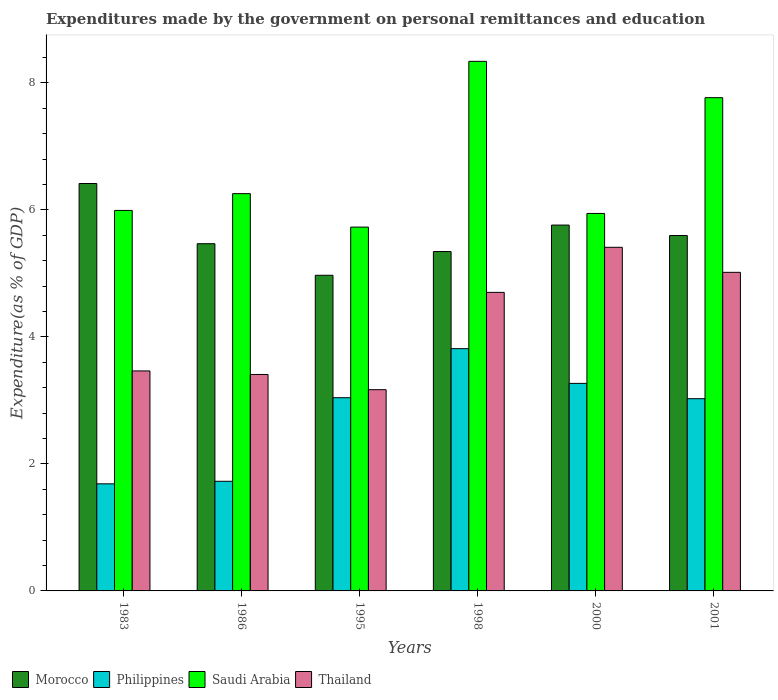Are the number of bars per tick equal to the number of legend labels?
Your answer should be very brief. Yes. How many bars are there on the 1st tick from the right?
Provide a succinct answer. 4. What is the label of the 5th group of bars from the left?
Make the answer very short. 2000. What is the expenditures made by the government on personal remittances and education in Thailand in 1983?
Your response must be concise. 3.46. Across all years, what is the maximum expenditures made by the government on personal remittances and education in Morocco?
Keep it short and to the point. 6.41. Across all years, what is the minimum expenditures made by the government on personal remittances and education in Thailand?
Keep it short and to the point. 3.17. In which year was the expenditures made by the government on personal remittances and education in Saudi Arabia maximum?
Offer a very short reply. 1998. In which year was the expenditures made by the government on personal remittances and education in Philippines minimum?
Offer a terse response. 1983. What is the total expenditures made by the government on personal remittances and education in Morocco in the graph?
Make the answer very short. 33.55. What is the difference between the expenditures made by the government on personal remittances and education in Saudi Arabia in 1995 and that in 1998?
Provide a short and direct response. -2.61. What is the difference between the expenditures made by the government on personal remittances and education in Thailand in 1986 and the expenditures made by the government on personal remittances and education in Philippines in 1998?
Your answer should be very brief. -0.41. What is the average expenditures made by the government on personal remittances and education in Morocco per year?
Provide a short and direct response. 5.59. In the year 1986, what is the difference between the expenditures made by the government on personal remittances and education in Morocco and expenditures made by the government on personal remittances and education in Philippines?
Provide a short and direct response. 3.74. What is the ratio of the expenditures made by the government on personal remittances and education in Thailand in 1998 to that in 2000?
Your response must be concise. 0.87. Is the expenditures made by the government on personal remittances and education in Morocco in 1983 less than that in 1998?
Keep it short and to the point. No. Is the difference between the expenditures made by the government on personal remittances and education in Morocco in 1995 and 2000 greater than the difference between the expenditures made by the government on personal remittances and education in Philippines in 1995 and 2000?
Provide a succinct answer. No. What is the difference between the highest and the second highest expenditures made by the government on personal remittances and education in Philippines?
Provide a short and direct response. 0.55. What is the difference between the highest and the lowest expenditures made by the government on personal remittances and education in Philippines?
Make the answer very short. 2.13. Is the sum of the expenditures made by the government on personal remittances and education in Morocco in 1983 and 1998 greater than the maximum expenditures made by the government on personal remittances and education in Philippines across all years?
Provide a succinct answer. Yes. Is it the case that in every year, the sum of the expenditures made by the government on personal remittances and education in Saudi Arabia and expenditures made by the government on personal remittances and education in Thailand is greater than the sum of expenditures made by the government on personal remittances and education in Philippines and expenditures made by the government on personal remittances and education in Morocco?
Keep it short and to the point. Yes. What does the 2nd bar from the left in 1995 represents?
Your response must be concise. Philippines. What does the 1st bar from the right in 1998 represents?
Ensure brevity in your answer.  Thailand. Is it the case that in every year, the sum of the expenditures made by the government on personal remittances and education in Morocco and expenditures made by the government on personal remittances and education in Thailand is greater than the expenditures made by the government on personal remittances and education in Saudi Arabia?
Provide a short and direct response. Yes. How many bars are there?
Your response must be concise. 24. Are all the bars in the graph horizontal?
Your response must be concise. No. What is the difference between two consecutive major ticks on the Y-axis?
Give a very brief answer. 2. How are the legend labels stacked?
Offer a very short reply. Horizontal. What is the title of the graph?
Offer a terse response. Expenditures made by the government on personal remittances and education. What is the label or title of the X-axis?
Make the answer very short. Years. What is the label or title of the Y-axis?
Your answer should be compact. Expenditure(as % of GDP). What is the Expenditure(as % of GDP) in Morocco in 1983?
Your response must be concise. 6.41. What is the Expenditure(as % of GDP) in Philippines in 1983?
Give a very brief answer. 1.69. What is the Expenditure(as % of GDP) of Saudi Arabia in 1983?
Make the answer very short. 5.99. What is the Expenditure(as % of GDP) in Thailand in 1983?
Keep it short and to the point. 3.46. What is the Expenditure(as % of GDP) of Morocco in 1986?
Keep it short and to the point. 5.47. What is the Expenditure(as % of GDP) in Philippines in 1986?
Your answer should be very brief. 1.73. What is the Expenditure(as % of GDP) of Saudi Arabia in 1986?
Your answer should be compact. 6.26. What is the Expenditure(as % of GDP) in Thailand in 1986?
Keep it short and to the point. 3.41. What is the Expenditure(as % of GDP) of Morocco in 1995?
Ensure brevity in your answer.  4.97. What is the Expenditure(as % of GDP) of Philippines in 1995?
Provide a succinct answer. 3.04. What is the Expenditure(as % of GDP) of Saudi Arabia in 1995?
Provide a short and direct response. 5.73. What is the Expenditure(as % of GDP) in Thailand in 1995?
Your answer should be compact. 3.17. What is the Expenditure(as % of GDP) in Morocco in 1998?
Your response must be concise. 5.34. What is the Expenditure(as % of GDP) in Philippines in 1998?
Offer a very short reply. 3.81. What is the Expenditure(as % of GDP) in Saudi Arabia in 1998?
Keep it short and to the point. 8.34. What is the Expenditure(as % of GDP) of Thailand in 1998?
Keep it short and to the point. 4.7. What is the Expenditure(as % of GDP) of Morocco in 2000?
Keep it short and to the point. 5.76. What is the Expenditure(as % of GDP) in Philippines in 2000?
Your answer should be compact. 3.27. What is the Expenditure(as % of GDP) in Saudi Arabia in 2000?
Make the answer very short. 5.94. What is the Expenditure(as % of GDP) in Thailand in 2000?
Your answer should be compact. 5.41. What is the Expenditure(as % of GDP) in Morocco in 2001?
Make the answer very short. 5.6. What is the Expenditure(as % of GDP) of Philippines in 2001?
Provide a succinct answer. 3.03. What is the Expenditure(as % of GDP) in Saudi Arabia in 2001?
Keep it short and to the point. 7.77. What is the Expenditure(as % of GDP) in Thailand in 2001?
Offer a terse response. 5.02. Across all years, what is the maximum Expenditure(as % of GDP) of Morocco?
Provide a succinct answer. 6.41. Across all years, what is the maximum Expenditure(as % of GDP) in Philippines?
Ensure brevity in your answer.  3.81. Across all years, what is the maximum Expenditure(as % of GDP) in Saudi Arabia?
Keep it short and to the point. 8.34. Across all years, what is the maximum Expenditure(as % of GDP) of Thailand?
Make the answer very short. 5.41. Across all years, what is the minimum Expenditure(as % of GDP) of Morocco?
Your response must be concise. 4.97. Across all years, what is the minimum Expenditure(as % of GDP) in Philippines?
Make the answer very short. 1.69. Across all years, what is the minimum Expenditure(as % of GDP) of Saudi Arabia?
Your answer should be compact. 5.73. Across all years, what is the minimum Expenditure(as % of GDP) of Thailand?
Your response must be concise. 3.17. What is the total Expenditure(as % of GDP) in Morocco in the graph?
Provide a succinct answer. 33.55. What is the total Expenditure(as % of GDP) of Philippines in the graph?
Make the answer very short. 16.56. What is the total Expenditure(as % of GDP) in Saudi Arabia in the graph?
Ensure brevity in your answer.  40.02. What is the total Expenditure(as % of GDP) of Thailand in the graph?
Make the answer very short. 25.17. What is the difference between the Expenditure(as % of GDP) in Morocco in 1983 and that in 1986?
Provide a short and direct response. 0.95. What is the difference between the Expenditure(as % of GDP) in Philippines in 1983 and that in 1986?
Give a very brief answer. -0.04. What is the difference between the Expenditure(as % of GDP) in Saudi Arabia in 1983 and that in 1986?
Offer a terse response. -0.26. What is the difference between the Expenditure(as % of GDP) of Thailand in 1983 and that in 1986?
Your answer should be very brief. 0.06. What is the difference between the Expenditure(as % of GDP) of Morocco in 1983 and that in 1995?
Your response must be concise. 1.44. What is the difference between the Expenditure(as % of GDP) of Philippines in 1983 and that in 1995?
Offer a terse response. -1.36. What is the difference between the Expenditure(as % of GDP) of Saudi Arabia in 1983 and that in 1995?
Offer a terse response. 0.26. What is the difference between the Expenditure(as % of GDP) of Thailand in 1983 and that in 1995?
Ensure brevity in your answer.  0.3. What is the difference between the Expenditure(as % of GDP) in Morocco in 1983 and that in 1998?
Your answer should be very brief. 1.07. What is the difference between the Expenditure(as % of GDP) of Philippines in 1983 and that in 1998?
Give a very brief answer. -2.13. What is the difference between the Expenditure(as % of GDP) of Saudi Arabia in 1983 and that in 1998?
Make the answer very short. -2.35. What is the difference between the Expenditure(as % of GDP) of Thailand in 1983 and that in 1998?
Provide a short and direct response. -1.24. What is the difference between the Expenditure(as % of GDP) of Morocco in 1983 and that in 2000?
Make the answer very short. 0.65. What is the difference between the Expenditure(as % of GDP) of Philippines in 1983 and that in 2000?
Ensure brevity in your answer.  -1.58. What is the difference between the Expenditure(as % of GDP) in Saudi Arabia in 1983 and that in 2000?
Your response must be concise. 0.05. What is the difference between the Expenditure(as % of GDP) of Thailand in 1983 and that in 2000?
Your answer should be compact. -1.95. What is the difference between the Expenditure(as % of GDP) in Morocco in 1983 and that in 2001?
Provide a succinct answer. 0.82. What is the difference between the Expenditure(as % of GDP) of Philippines in 1983 and that in 2001?
Keep it short and to the point. -1.34. What is the difference between the Expenditure(as % of GDP) of Saudi Arabia in 1983 and that in 2001?
Make the answer very short. -1.78. What is the difference between the Expenditure(as % of GDP) in Thailand in 1983 and that in 2001?
Ensure brevity in your answer.  -1.55. What is the difference between the Expenditure(as % of GDP) of Morocco in 1986 and that in 1995?
Provide a succinct answer. 0.5. What is the difference between the Expenditure(as % of GDP) of Philippines in 1986 and that in 1995?
Provide a short and direct response. -1.32. What is the difference between the Expenditure(as % of GDP) of Saudi Arabia in 1986 and that in 1995?
Provide a succinct answer. 0.53. What is the difference between the Expenditure(as % of GDP) of Thailand in 1986 and that in 1995?
Your answer should be compact. 0.24. What is the difference between the Expenditure(as % of GDP) in Morocco in 1986 and that in 1998?
Provide a short and direct response. 0.12. What is the difference between the Expenditure(as % of GDP) of Philippines in 1986 and that in 1998?
Your answer should be very brief. -2.09. What is the difference between the Expenditure(as % of GDP) in Saudi Arabia in 1986 and that in 1998?
Your response must be concise. -2.08. What is the difference between the Expenditure(as % of GDP) of Thailand in 1986 and that in 1998?
Give a very brief answer. -1.29. What is the difference between the Expenditure(as % of GDP) of Morocco in 1986 and that in 2000?
Your response must be concise. -0.29. What is the difference between the Expenditure(as % of GDP) in Philippines in 1986 and that in 2000?
Make the answer very short. -1.54. What is the difference between the Expenditure(as % of GDP) in Saudi Arabia in 1986 and that in 2000?
Your response must be concise. 0.31. What is the difference between the Expenditure(as % of GDP) of Thailand in 1986 and that in 2000?
Keep it short and to the point. -2. What is the difference between the Expenditure(as % of GDP) of Morocco in 1986 and that in 2001?
Provide a short and direct response. -0.13. What is the difference between the Expenditure(as % of GDP) of Philippines in 1986 and that in 2001?
Ensure brevity in your answer.  -1.3. What is the difference between the Expenditure(as % of GDP) in Saudi Arabia in 1986 and that in 2001?
Your response must be concise. -1.51. What is the difference between the Expenditure(as % of GDP) of Thailand in 1986 and that in 2001?
Provide a short and direct response. -1.61. What is the difference between the Expenditure(as % of GDP) in Morocco in 1995 and that in 1998?
Your answer should be compact. -0.37. What is the difference between the Expenditure(as % of GDP) in Philippines in 1995 and that in 1998?
Provide a short and direct response. -0.77. What is the difference between the Expenditure(as % of GDP) of Saudi Arabia in 1995 and that in 1998?
Your response must be concise. -2.61. What is the difference between the Expenditure(as % of GDP) in Thailand in 1995 and that in 1998?
Keep it short and to the point. -1.53. What is the difference between the Expenditure(as % of GDP) in Morocco in 1995 and that in 2000?
Provide a short and direct response. -0.79. What is the difference between the Expenditure(as % of GDP) of Philippines in 1995 and that in 2000?
Keep it short and to the point. -0.23. What is the difference between the Expenditure(as % of GDP) in Saudi Arabia in 1995 and that in 2000?
Your answer should be very brief. -0.22. What is the difference between the Expenditure(as % of GDP) in Thailand in 1995 and that in 2000?
Your answer should be compact. -2.24. What is the difference between the Expenditure(as % of GDP) of Morocco in 1995 and that in 2001?
Your answer should be very brief. -0.63. What is the difference between the Expenditure(as % of GDP) in Philippines in 1995 and that in 2001?
Give a very brief answer. 0.02. What is the difference between the Expenditure(as % of GDP) in Saudi Arabia in 1995 and that in 2001?
Offer a terse response. -2.04. What is the difference between the Expenditure(as % of GDP) in Thailand in 1995 and that in 2001?
Provide a short and direct response. -1.85. What is the difference between the Expenditure(as % of GDP) of Morocco in 1998 and that in 2000?
Offer a very short reply. -0.42. What is the difference between the Expenditure(as % of GDP) of Philippines in 1998 and that in 2000?
Your answer should be compact. 0.55. What is the difference between the Expenditure(as % of GDP) of Saudi Arabia in 1998 and that in 2000?
Offer a very short reply. 2.39. What is the difference between the Expenditure(as % of GDP) of Thailand in 1998 and that in 2000?
Your answer should be compact. -0.71. What is the difference between the Expenditure(as % of GDP) of Morocco in 1998 and that in 2001?
Offer a very short reply. -0.25. What is the difference between the Expenditure(as % of GDP) in Philippines in 1998 and that in 2001?
Offer a terse response. 0.79. What is the difference between the Expenditure(as % of GDP) in Saudi Arabia in 1998 and that in 2001?
Your answer should be very brief. 0.57. What is the difference between the Expenditure(as % of GDP) in Thailand in 1998 and that in 2001?
Provide a succinct answer. -0.32. What is the difference between the Expenditure(as % of GDP) of Morocco in 2000 and that in 2001?
Your response must be concise. 0.16. What is the difference between the Expenditure(as % of GDP) in Philippines in 2000 and that in 2001?
Make the answer very short. 0.24. What is the difference between the Expenditure(as % of GDP) in Saudi Arabia in 2000 and that in 2001?
Make the answer very short. -1.82. What is the difference between the Expenditure(as % of GDP) in Thailand in 2000 and that in 2001?
Your answer should be compact. 0.39. What is the difference between the Expenditure(as % of GDP) in Morocco in 1983 and the Expenditure(as % of GDP) in Philippines in 1986?
Offer a very short reply. 4.69. What is the difference between the Expenditure(as % of GDP) of Morocco in 1983 and the Expenditure(as % of GDP) of Saudi Arabia in 1986?
Offer a terse response. 0.16. What is the difference between the Expenditure(as % of GDP) in Morocco in 1983 and the Expenditure(as % of GDP) in Thailand in 1986?
Ensure brevity in your answer.  3.01. What is the difference between the Expenditure(as % of GDP) in Philippines in 1983 and the Expenditure(as % of GDP) in Saudi Arabia in 1986?
Offer a terse response. -4.57. What is the difference between the Expenditure(as % of GDP) of Philippines in 1983 and the Expenditure(as % of GDP) of Thailand in 1986?
Ensure brevity in your answer.  -1.72. What is the difference between the Expenditure(as % of GDP) in Saudi Arabia in 1983 and the Expenditure(as % of GDP) in Thailand in 1986?
Provide a succinct answer. 2.58. What is the difference between the Expenditure(as % of GDP) of Morocco in 1983 and the Expenditure(as % of GDP) of Philippines in 1995?
Your answer should be very brief. 3.37. What is the difference between the Expenditure(as % of GDP) in Morocco in 1983 and the Expenditure(as % of GDP) in Saudi Arabia in 1995?
Keep it short and to the point. 0.69. What is the difference between the Expenditure(as % of GDP) of Morocco in 1983 and the Expenditure(as % of GDP) of Thailand in 1995?
Your response must be concise. 3.25. What is the difference between the Expenditure(as % of GDP) in Philippines in 1983 and the Expenditure(as % of GDP) in Saudi Arabia in 1995?
Your answer should be compact. -4.04. What is the difference between the Expenditure(as % of GDP) in Philippines in 1983 and the Expenditure(as % of GDP) in Thailand in 1995?
Keep it short and to the point. -1.48. What is the difference between the Expenditure(as % of GDP) of Saudi Arabia in 1983 and the Expenditure(as % of GDP) of Thailand in 1995?
Offer a terse response. 2.82. What is the difference between the Expenditure(as % of GDP) in Morocco in 1983 and the Expenditure(as % of GDP) in Philippines in 1998?
Provide a short and direct response. 2.6. What is the difference between the Expenditure(as % of GDP) of Morocco in 1983 and the Expenditure(as % of GDP) of Saudi Arabia in 1998?
Ensure brevity in your answer.  -1.92. What is the difference between the Expenditure(as % of GDP) of Morocco in 1983 and the Expenditure(as % of GDP) of Thailand in 1998?
Keep it short and to the point. 1.71. What is the difference between the Expenditure(as % of GDP) in Philippines in 1983 and the Expenditure(as % of GDP) in Saudi Arabia in 1998?
Provide a short and direct response. -6.65. What is the difference between the Expenditure(as % of GDP) of Philippines in 1983 and the Expenditure(as % of GDP) of Thailand in 1998?
Your answer should be very brief. -3.01. What is the difference between the Expenditure(as % of GDP) of Saudi Arabia in 1983 and the Expenditure(as % of GDP) of Thailand in 1998?
Give a very brief answer. 1.29. What is the difference between the Expenditure(as % of GDP) in Morocco in 1983 and the Expenditure(as % of GDP) in Philippines in 2000?
Provide a short and direct response. 3.15. What is the difference between the Expenditure(as % of GDP) in Morocco in 1983 and the Expenditure(as % of GDP) in Saudi Arabia in 2000?
Ensure brevity in your answer.  0.47. What is the difference between the Expenditure(as % of GDP) of Philippines in 1983 and the Expenditure(as % of GDP) of Saudi Arabia in 2000?
Your answer should be very brief. -4.26. What is the difference between the Expenditure(as % of GDP) in Philippines in 1983 and the Expenditure(as % of GDP) in Thailand in 2000?
Give a very brief answer. -3.72. What is the difference between the Expenditure(as % of GDP) of Saudi Arabia in 1983 and the Expenditure(as % of GDP) of Thailand in 2000?
Give a very brief answer. 0.58. What is the difference between the Expenditure(as % of GDP) of Morocco in 1983 and the Expenditure(as % of GDP) of Philippines in 2001?
Offer a terse response. 3.39. What is the difference between the Expenditure(as % of GDP) in Morocco in 1983 and the Expenditure(as % of GDP) in Saudi Arabia in 2001?
Provide a succinct answer. -1.35. What is the difference between the Expenditure(as % of GDP) of Morocco in 1983 and the Expenditure(as % of GDP) of Thailand in 2001?
Provide a short and direct response. 1.4. What is the difference between the Expenditure(as % of GDP) in Philippines in 1983 and the Expenditure(as % of GDP) in Saudi Arabia in 2001?
Provide a succinct answer. -6.08. What is the difference between the Expenditure(as % of GDP) in Philippines in 1983 and the Expenditure(as % of GDP) in Thailand in 2001?
Provide a succinct answer. -3.33. What is the difference between the Expenditure(as % of GDP) in Saudi Arabia in 1983 and the Expenditure(as % of GDP) in Thailand in 2001?
Ensure brevity in your answer.  0.97. What is the difference between the Expenditure(as % of GDP) of Morocco in 1986 and the Expenditure(as % of GDP) of Philippines in 1995?
Offer a terse response. 2.42. What is the difference between the Expenditure(as % of GDP) of Morocco in 1986 and the Expenditure(as % of GDP) of Saudi Arabia in 1995?
Make the answer very short. -0.26. What is the difference between the Expenditure(as % of GDP) of Morocco in 1986 and the Expenditure(as % of GDP) of Thailand in 1995?
Your answer should be very brief. 2.3. What is the difference between the Expenditure(as % of GDP) in Philippines in 1986 and the Expenditure(as % of GDP) in Saudi Arabia in 1995?
Provide a succinct answer. -4. What is the difference between the Expenditure(as % of GDP) of Philippines in 1986 and the Expenditure(as % of GDP) of Thailand in 1995?
Your answer should be compact. -1.44. What is the difference between the Expenditure(as % of GDP) in Saudi Arabia in 1986 and the Expenditure(as % of GDP) in Thailand in 1995?
Make the answer very short. 3.09. What is the difference between the Expenditure(as % of GDP) in Morocco in 1986 and the Expenditure(as % of GDP) in Philippines in 1998?
Keep it short and to the point. 1.65. What is the difference between the Expenditure(as % of GDP) of Morocco in 1986 and the Expenditure(as % of GDP) of Saudi Arabia in 1998?
Keep it short and to the point. -2.87. What is the difference between the Expenditure(as % of GDP) of Morocco in 1986 and the Expenditure(as % of GDP) of Thailand in 1998?
Your answer should be very brief. 0.77. What is the difference between the Expenditure(as % of GDP) of Philippines in 1986 and the Expenditure(as % of GDP) of Saudi Arabia in 1998?
Make the answer very short. -6.61. What is the difference between the Expenditure(as % of GDP) of Philippines in 1986 and the Expenditure(as % of GDP) of Thailand in 1998?
Your answer should be compact. -2.97. What is the difference between the Expenditure(as % of GDP) in Saudi Arabia in 1986 and the Expenditure(as % of GDP) in Thailand in 1998?
Give a very brief answer. 1.55. What is the difference between the Expenditure(as % of GDP) of Morocco in 1986 and the Expenditure(as % of GDP) of Philippines in 2000?
Provide a succinct answer. 2.2. What is the difference between the Expenditure(as % of GDP) in Morocco in 1986 and the Expenditure(as % of GDP) in Saudi Arabia in 2000?
Provide a short and direct response. -0.48. What is the difference between the Expenditure(as % of GDP) in Morocco in 1986 and the Expenditure(as % of GDP) in Thailand in 2000?
Your answer should be compact. 0.06. What is the difference between the Expenditure(as % of GDP) of Philippines in 1986 and the Expenditure(as % of GDP) of Saudi Arabia in 2000?
Keep it short and to the point. -4.22. What is the difference between the Expenditure(as % of GDP) of Philippines in 1986 and the Expenditure(as % of GDP) of Thailand in 2000?
Offer a terse response. -3.68. What is the difference between the Expenditure(as % of GDP) of Saudi Arabia in 1986 and the Expenditure(as % of GDP) of Thailand in 2000?
Your answer should be very brief. 0.84. What is the difference between the Expenditure(as % of GDP) of Morocco in 1986 and the Expenditure(as % of GDP) of Philippines in 2001?
Offer a terse response. 2.44. What is the difference between the Expenditure(as % of GDP) of Morocco in 1986 and the Expenditure(as % of GDP) of Saudi Arabia in 2001?
Your answer should be compact. -2.3. What is the difference between the Expenditure(as % of GDP) in Morocco in 1986 and the Expenditure(as % of GDP) in Thailand in 2001?
Give a very brief answer. 0.45. What is the difference between the Expenditure(as % of GDP) in Philippines in 1986 and the Expenditure(as % of GDP) in Saudi Arabia in 2001?
Your answer should be very brief. -6.04. What is the difference between the Expenditure(as % of GDP) in Philippines in 1986 and the Expenditure(as % of GDP) in Thailand in 2001?
Keep it short and to the point. -3.29. What is the difference between the Expenditure(as % of GDP) in Saudi Arabia in 1986 and the Expenditure(as % of GDP) in Thailand in 2001?
Your answer should be compact. 1.24. What is the difference between the Expenditure(as % of GDP) in Morocco in 1995 and the Expenditure(as % of GDP) in Philippines in 1998?
Provide a succinct answer. 1.16. What is the difference between the Expenditure(as % of GDP) in Morocco in 1995 and the Expenditure(as % of GDP) in Saudi Arabia in 1998?
Your answer should be very brief. -3.37. What is the difference between the Expenditure(as % of GDP) in Morocco in 1995 and the Expenditure(as % of GDP) in Thailand in 1998?
Your answer should be very brief. 0.27. What is the difference between the Expenditure(as % of GDP) in Philippines in 1995 and the Expenditure(as % of GDP) in Saudi Arabia in 1998?
Keep it short and to the point. -5.3. What is the difference between the Expenditure(as % of GDP) in Philippines in 1995 and the Expenditure(as % of GDP) in Thailand in 1998?
Make the answer very short. -1.66. What is the difference between the Expenditure(as % of GDP) in Saudi Arabia in 1995 and the Expenditure(as % of GDP) in Thailand in 1998?
Your response must be concise. 1.03. What is the difference between the Expenditure(as % of GDP) of Morocco in 1995 and the Expenditure(as % of GDP) of Philippines in 2000?
Make the answer very short. 1.7. What is the difference between the Expenditure(as % of GDP) of Morocco in 1995 and the Expenditure(as % of GDP) of Saudi Arabia in 2000?
Give a very brief answer. -0.97. What is the difference between the Expenditure(as % of GDP) of Morocco in 1995 and the Expenditure(as % of GDP) of Thailand in 2000?
Offer a terse response. -0.44. What is the difference between the Expenditure(as % of GDP) of Philippines in 1995 and the Expenditure(as % of GDP) of Saudi Arabia in 2000?
Keep it short and to the point. -2.9. What is the difference between the Expenditure(as % of GDP) of Philippines in 1995 and the Expenditure(as % of GDP) of Thailand in 2000?
Your response must be concise. -2.37. What is the difference between the Expenditure(as % of GDP) of Saudi Arabia in 1995 and the Expenditure(as % of GDP) of Thailand in 2000?
Offer a very short reply. 0.32. What is the difference between the Expenditure(as % of GDP) of Morocco in 1995 and the Expenditure(as % of GDP) of Philippines in 2001?
Give a very brief answer. 1.94. What is the difference between the Expenditure(as % of GDP) of Morocco in 1995 and the Expenditure(as % of GDP) of Saudi Arabia in 2001?
Ensure brevity in your answer.  -2.8. What is the difference between the Expenditure(as % of GDP) of Morocco in 1995 and the Expenditure(as % of GDP) of Thailand in 2001?
Provide a short and direct response. -0.05. What is the difference between the Expenditure(as % of GDP) of Philippines in 1995 and the Expenditure(as % of GDP) of Saudi Arabia in 2001?
Give a very brief answer. -4.72. What is the difference between the Expenditure(as % of GDP) in Philippines in 1995 and the Expenditure(as % of GDP) in Thailand in 2001?
Your answer should be very brief. -1.97. What is the difference between the Expenditure(as % of GDP) in Saudi Arabia in 1995 and the Expenditure(as % of GDP) in Thailand in 2001?
Ensure brevity in your answer.  0.71. What is the difference between the Expenditure(as % of GDP) of Morocco in 1998 and the Expenditure(as % of GDP) of Philippines in 2000?
Offer a terse response. 2.08. What is the difference between the Expenditure(as % of GDP) in Morocco in 1998 and the Expenditure(as % of GDP) in Saudi Arabia in 2000?
Offer a terse response. -0.6. What is the difference between the Expenditure(as % of GDP) in Morocco in 1998 and the Expenditure(as % of GDP) in Thailand in 2000?
Your answer should be compact. -0.07. What is the difference between the Expenditure(as % of GDP) in Philippines in 1998 and the Expenditure(as % of GDP) in Saudi Arabia in 2000?
Offer a very short reply. -2.13. What is the difference between the Expenditure(as % of GDP) of Philippines in 1998 and the Expenditure(as % of GDP) of Thailand in 2000?
Your answer should be compact. -1.6. What is the difference between the Expenditure(as % of GDP) of Saudi Arabia in 1998 and the Expenditure(as % of GDP) of Thailand in 2000?
Offer a terse response. 2.93. What is the difference between the Expenditure(as % of GDP) in Morocco in 1998 and the Expenditure(as % of GDP) in Philippines in 2001?
Make the answer very short. 2.32. What is the difference between the Expenditure(as % of GDP) of Morocco in 1998 and the Expenditure(as % of GDP) of Saudi Arabia in 2001?
Offer a very short reply. -2.42. What is the difference between the Expenditure(as % of GDP) in Morocco in 1998 and the Expenditure(as % of GDP) in Thailand in 2001?
Offer a terse response. 0.33. What is the difference between the Expenditure(as % of GDP) of Philippines in 1998 and the Expenditure(as % of GDP) of Saudi Arabia in 2001?
Keep it short and to the point. -3.95. What is the difference between the Expenditure(as % of GDP) of Philippines in 1998 and the Expenditure(as % of GDP) of Thailand in 2001?
Offer a terse response. -1.2. What is the difference between the Expenditure(as % of GDP) in Saudi Arabia in 1998 and the Expenditure(as % of GDP) in Thailand in 2001?
Make the answer very short. 3.32. What is the difference between the Expenditure(as % of GDP) in Morocco in 2000 and the Expenditure(as % of GDP) in Philippines in 2001?
Provide a succinct answer. 2.73. What is the difference between the Expenditure(as % of GDP) of Morocco in 2000 and the Expenditure(as % of GDP) of Saudi Arabia in 2001?
Provide a succinct answer. -2.01. What is the difference between the Expenditure(as % of GDP) of Morocco in 2000 and the Expenditure(as % of GDP) of Thailand in 2001?
Provide a succinct answer. 0.74. What is the difference between the Expenditure(as % of GDP) in Philippines in 2000 and the Expenditure(as % of GDP) in Saudi Arabia in 2001?
Your response must be concise. -4.5. What is the difference between the Expenditure(as % of GDP) of Philippines in 2000 and the Expenditure(as % of GDP) of Thailand in 2001?
Make the answer very short. -1.75. What is the difference between the Expenditure(as % of GDP) of Saudi Arabia in 2000 and the Expenditure(as % of GDP) of Thailand in 2001?
Make the answer very short. 0.93. What is the average Expenditure(as % of GDP) in Morocco per year?
Provide a short and direct response. 5.59. What is the average Expenditure(as % of GDP) of Philippines per year?
Give a very brief answer. 2.76. What is the average Expenditure(as % of GDP) of Saudi Arabia per year?
Provide a succinct answer. 6.67. What is the average Expenditure(as % of GDP) in Thailand per year?
Provide a short and direct response. 4.19. In the year 1983, what is the difference between the Expenditure(as % of GDP) of Morocco and Expenditure(as % of GDP) of Philippines?
Provide a succinct answer. 4.73. In the year 1983, what is the difference between the Expenditure(as % of GDP) of Morocco and Expenditure(as % of GDP) of Saudi Arabia?
Your answer should be very brief. 0.42. In the year 1983, what is the difference between the Expenditure(as % of GDP) in Morocco and Expenditure(as % of GDP) in Thailand?
Make the answer very short. 2.95. In the year 1983, what is the difference between the Expenditure(as % of GDP) of Philippines and Expenditure(as % of GDP) of Saudi Arabia?
Your answer should be compact. -4.3. In the year 1983, what is the difference between the Expenditure(as % of GDP) in Philippines and Expenditure(as % of GDP) in Thailand?
Your response must be concise. -1.78. In the year 1983, what is the difference between the Expenditure(as % of GDP) of Saudi Arabia and Expenditure(as % of GDP) of Thailand?
Your response must be concise. 2.53. In the year 1986, what is the difference between the Expenditure(as % of GDP) of Morocco and Expenditure(as % of GDP) of Philippines?
Your response must be concise. 3.74. In the year 1986, what is the difference between the Expenditure(as % of GDP) of Morocco and Expenditure(as % of GDP) of Saudi Arabia?
Make the answer very short. -0.79. In the year 1986, what is the difference between the Expenditure(as % of GDP) in Morocco and Expenditure(as % of GDP) in Thailand?
Your answer should be very brief. 2.06. In the year 1986, what is the difference between the Expenditure(as % of GDP) of Philippines and Expenditure(as % of GDP) of Saudi Arabia?
Your answer should be very brief. -4.53. In the year 1986, what is the difference between the Expenditure(as % of GDP) in Philippines and Expenditure(as % of GDP) in Thailand?
Provide a short and direct response. -1.68. In the year 1986, what is the difference between the Expenditure(as % of GDP) in Saudi Arabia and Expenditure(as % of GDP) in Thailand?
Give a very brief answer. 2.85. In the year 1995, what is the difference between the Expenditure(as % of GDP) in Morocco and Expenditure(as % of GDP) in Philippines?
Make the answer very short. 1.93. In the year 1995, what is the difference between the Expenditure(as % of GDP) in Morocco and Expenditure(as % of GDP) in Saudi Arabia?
Offer a terse response. -0.76. In the year 1995, what is the difference between the Expenditure(as % of GDP) of Morocco and Expenditure(as % of GDP) of Thailand?
Provide a succinct answer. 1.8. In the year 1995, what is the difference between the Expenditure(as % of GDP) of Philippines and Expenditure(as % of GDP) of Saudi Arabia?
Give a very brief answer. -2.69. In the year 1995, what is the difference between the Expenditure(as % of GDP) of Philippines and Expenditure(as % of GDP) of Thailand?
Provide a short and direct response. -0.13. In the year 1995, what is the difference between the Expenditure(as % of GDP) of Saudi Arabia and Expenditure(as % of GDP) of Thailand?
Make the answer very short. 2.56. In the year 1998, what is the difference between the Expenditure(as % of GDP) of Morocco and Expenditure(as % of GDP) of Philippines?
Provide a short and direct response. 1.53. In the year 1998, what is the difference between the Expenditure(as % of GDP) in Morocco and Expenditure(as % of GDP) in Saudi Arabia?
Your response must be concise. -2.99. In the year 1998, what is the difference between the Expenditure(as % of GDP) of Morocco and Expenditure(as % of GDP) of Thailand?
Your answer should be very brief. 0.64. In the year 1998, what is the difference between the Expenditure(as % of GDP) in Philippines and Expenditure(as % of GDP) in Saudi Arabia?
Offer a terse response. -4.52. In the year 1998, what is the difference between the Expenditure(as % of GDP) of Philippines and Expenditure(as % of GDP) of Thailand?
Provide a succinct answer. -0.89. In the year 1998, what is the difference between the Expenditure(as % of GDP) of Saudi Arabia and Expenditure(as % of GDP) of Thailand?
Offer a very short reply. 3.64. In the year 2000, what is the difference between the Expenditure(as % of GDP) of Morocco and Expenditure(as % of GDP) of Philippines?
Offer a terse response. 2.49. In the year 2000, what is the difference between the Expenditure(as % of GDP) in Morocco and Expenditure(as % of GDP) in Saudi Arabia?
Make the answer very short. -0.18. In the year 2000, what is the difference between the Expenditure(as % of GDP) in Morocco and Expenditure(as % of GDP) in Thailand?
Make the answer very short. 0.35. In the year 2000, what is the difference between the Expenditure(as % of GDP) of Philippines and Expenditure(as % of GDP) of Saudi Arabia?
Offer a terse response. -2.68. In the year 2000, what is the difference between the Expenditure(as % of GDP) in Philippines and Expenditure(as % of GDP) in Thailand?
Your answer should be very brief. -2.14. In the year 2000, what is the difference between the Expenditure(as % of GDP) of Saudi Arabia and Expenditure(as % of GDP) of Thailand?
Offer a very short reply. 0.53. In the year 2001, what is the difference between the Expenditure(as % of GDP) in Morocco and Expenditure(as % of GDP) in Philippines?
Offer a very short reply. 2.57. In the year 2001, what is the difference between the Expenditure(as % of GDP) in Morocco and Expenditure(as % of GDP) in Saudi Arabia?
Ensure brevity in your answer.  -2.17. In the year 2001, what is the difference between the Expenditure(as % of GDP) in Morocco and Expenditure(as % of GDP) in Thailand?
Provide a short and direct response. 0.58. In the year 2001, what is the difference between the Expenditure(as % of GDP) in Philippines and Expenditure(as % of GDP) in Saudi Arabia?
Offer a terse response. -4.74. In the year 2001, what is the difference between the Expenditure(as % of GDP) of Philippines and Expenditure(as % of GDP) of Thailand?
Your response must be concise. -1.99. In the year 2001, what is the difference between the Expenditure(as % of GDP) in Saudi Arabia and Expenditure(as % of GDP) in Thailand?
Keep it short and to the point. 2.75. What is the ratio of the Expenditure(as % of GDP) in Morocco in 1983 to that in 1986?
Keep it short and to the point. 1.17. What is the ratio of the Expenditure(as % of GDP) in Philippines in 1983 to that in 1986?
Give a very brief answer. 0.98. What is the ratio of the Expenditure(as % of GDP) in Saudi Arabia in 1983 to that in 1986?
Offer a very short reply. 0.96. What is the ratio of the Expenditure(as % of GDP) in Thailand in 1983 to that in 1986?
Provide a short and direct response. 1.02. What is the ratio of the Expenditure(as % of GDP) in Morocco in 1983 to that in 1995?
Give a very brief answer. 1.29. What is the ratio of the Expenditure(as % of GDP) of Philippines in 1983 to that in 1995?
Give a very brief answer. 0.55. What is the ratio of the Expenditure(as % of GDP) of Saudi Arabia in 1983 to that in 1995?
Provide a short and direct response. 1.05. What is the ratio of the Expenditure(as % of GDP) of Thailand in 1983 to that in 1995?
Your response must be concise. 1.09. What is the ratio of the Expenditure(as % of GDP) of Morocco in 1983 to that in 1998?
Your response must be concise. 1.2. What is the ratio of the Expenditure(as % of GDP) in Philippines in 1983 to that in 1998?
Offer a very short reply. 0.44. What is the ratio of the Expenditure(as % of GDP) in Saudi Arabia in 1983 to that in 1998?
Your answer should be compact. 0.72. What is the ratio of the Expenditure(as % of GDP) of Thailand in 1983 to that in 1998?
Offer a very short reply. 0.74. What is the ratio of the Expenditure(as % of GDP) in Morocco in 1983 to that in 2000?
Give a very brief answer. 1.11. What is the ratio of the Expenditure(as % of GDP) in Philippines in 1983 to that in 2000?
Provide a short and direct response. 0.52. What is the ratio of the Expenditure(as % of GDP) in Thailand in 1983 to that in 2000?
Provide a succinct answer. 0.64. What is the ratio of the Expenditure(as % of GDP) in Morocco in 1983 to that in 2001?
Your response must be concise. 1.15. What is the ratio of the Expenditure(as % of GDP) of Philippines in 1983 to that in 2001?
Provide a succinct answer. 0.56. What is the ratio of the Expenditure(as % of GDP) of Saudi Arabia in 1983 to that in 2001?
Offer a very short reply. 0.77. What is the ratio of the Expenditure(as % of GDP) in Thailand in 1983 to that in 2001?
Offer a very short reply. 0.69. What is the ratio of the Expenditure(as % of GDP) in Philippines in 1986 to that in 1995?
Ensure brevity in your answer.  0.57. What is the ratio of the Expenditure(as % of GDP) of Saudi Arabia in 1986 to that in 1995?
Provide a succinct answer. 1.09. What is the ratio of the Expenditure(as % of GDP) of Thailand in 1986 to that in 1995?
Offer a terse response. 1.08. What is the ratio of the Expenditure(as % of GDP) of Morocco in 1986 to that in 1998?
Provide a succinct answer. 1.02. What is the ratio of the Expenditure(as % of GDP) of Philippines in 1986 to that in 1998?
Offer a terse response. 0.45. What is the ratio of the Expenditure(as % of GDP) of Saudi Arabia in 1986 to that in 1998?
Ensure brevity in your answer.  0.75. What is the ratio of the Expenditure(as % of GDP) in Thailand in 1986 to that in 1998?
Make the answer very short. 0.72. What is the ratio of the Expenditure(as % of GDP) in Morocco in 1986 to that in 2000?
Make the answer very short. 0.95. What is the ratio of the Expenditure(as % of GDP) in Philippines in 1986 to that in 2000?
Offer a terse response. 0.53. What is the ratio of the Expenditure(as % of GDP) in Saudi Arabia in 1986 to that in 2000?
Keep it short and to the point. 1.05. What is the ratio of the Expenditure(as % of GDP) of Thailand in 1986 to that in 2000?
Give a very brief answer. 0.63. What is the ratio of the Expenditure(as % of GDP) in Philippines in 1986 to that in 2001?
Provide a succinct answer. 0.57. What is the ratio of the Expenditure(as % of GDP) of Saudi Arabia in 1986 to that in 2001?
Make the answer very short. 0.81. What is the ratio of the Expenditure(as % of GDP) in Thailand in 1986 to that in 2001?
Provide a short and direct response. 0.68. What is the ratio of the Expenditure(as % of GDP) in Morocco in 1995 to that in 1998?
Your answer should be compact. 0.93. What is the ratio of the Expenditure(as % of GDP) of Philippines in 1995 to that in 1998?
Make the answer very short. 0.8. What is the ratio of the Expenditure(as % of GDP) in Saudi Arabia in 1995 to that in 1998?
Make the answer very short. 0.69. What is the ratio of the Expenditure(as % of GDP) in Thailand in 1995 to that in 1998?
Give a very brief answer. 0.67. What is the ratio of the Expenditure(as % of GDP) in Morocco in 1995 to that in 2000?
Offer a terse response. 0.86. What is the ratio of the Expenditure(as % of GDP) of Philippines in 1995 to that in 2000?
Ensure brevity in your answer.  0.93. What is the ratio of the Expenditure(as % of GDP) of Saudi Arabia in 1995 to that in 2000?
Ensure brevity in your answer.  0.96. What is the ratio of the Expenditure(as % of GDP) in Thailand in 1995 to that in 2000?
Offer a terse response. 0.59. What is the ratio of the Expenditure(as % of GDP) of Morocco in 1995 to that in 2001?
Keep it short and to the point. 0.89. What is the ratio of the Expenditure(as % of GDP) in Saudi Arabia in 1995 to that in 2001?
Make the answer very short. 0.74. What is the ratio of the Expenditure(as % of GDP) of Thailand in 1995 to that in 2001?
Keep it short and to the point. 0.63. What is the ratio of the Expenditure(as % of GDP) in Morocco in 1998 to that in 2000?
Give a very brief answer. 0.93. What is the ratio of the Expenditure(as % of GDP) in Philippines in 1998 to that in 2000?
Keep it short and to the point. 1.17. What is the ratio of the Expenditure(as % of GDP) of Saudi Arabia in 1998 to that in 2000?
Offer a very short reply. 1.4. What is the ratio of the Expenditure(as % of GDP) of Thailand in 1998 to that in 2000?
Offer a terse response. 0.87. What is the ratio of the Expenditure(as % of GDP) in Morocco in 1998 to that in 2001?
Give a very brief answer. 0.95. What is the ratio of the Expenditure(as % of GDP) in Philippines in 1998 to that in 2001?
Make the answer very short. 1.26. What is the ratio of the Expenditure(as % of GDP) in Saudi Arabia in 1998 to that in 2001?
Make the answer very short. 1.07. What is the ratio of the Expenditure(as % of GDP) of Thailand in 1998 to that in 2001?
Offer a terse response. 0.94. What is the ratio of the Expenditure(as % of GDP) of Morocco in 2000 to that in 2001?
Provide a short and direct response. 1.03. What is the ratio of the Expenditure(as % of GDP) of Philippines in 2000 to that in 2001?
Offer a terse response. 1.08. What is the ratio of the Expenditure(as % of GDP) of Saudi Arabia in 2000 to that in 2001?
Ensure brevity in your answer.  0.77. What is the ratio of the Expenditure(as % of GDP) in Thailand in 2000 to that in 2001?
Your answer should be very brief. 1.08. What is the difference between the highest and the second highest Expenditure(as % of GDP) of Morocco?
Provide a short and direct response. 0.65. What is the difference between the highest and the second highest Expenditure(as % of GDP) in Philippines?
Make the answer very short. 0.55. What is the difference between the highest and the second highest Expenditure(as % of GDP) of Saudi Arabia?
Make the answer very short. 0.57. What is the difference between the highest and the second highest Expenditure(as % of GDP) of Thailand?
Provide a short and direct response. 0.39. What is the difference between the highest and the lowest Expenditure(as % of GDP) of Morocco?
Keep it short and to the point. 1.44. What is the difference between the highest and the lowest Expenditure(as % of GDP) of Philippines?
Offer a terse response. 2.13. What is the difference between the highest and the lowest Expenditure(as % of GDP) in Saudi Arabia?
Your response must be concise. 2.61. What is the difference between the highest and the lowest Expenditure(as % of GDP) of Thailand?
Provide a succinct answer. 2.24. 